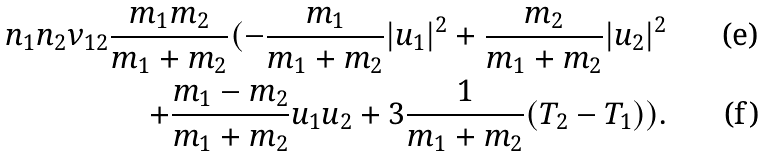Convert formula to latex. <formula><loc_0><loc_0><loc_500><loc_500>n _ { 1 } n _ { 2 } \nu _ { 1 2 } \frac { m _ { 1 } m _ { 2 } } { m _ { 1 } + m _ { 2 } } ( - \frac { m _ { 1 } } { m _ { 1 } + m _ { 2 } } | u _ { 1 } | ^ { 2 } + \frac { m _ { 2 } } { m _ { 1 } + m _ { 2 } } | u _ { 2 } | ^ { 2 } \\ + \frac { m _ { 1 } - m _ { 2 } } { m _ { 1 } + m _ { 2 } } u _ { 1 } u _ { 2 } + 3 \frac { 1 } { m _ { 1 } + m _ { 2 } } ( T _ { 2 } - T _ { 1 } ) ) .</formula> 